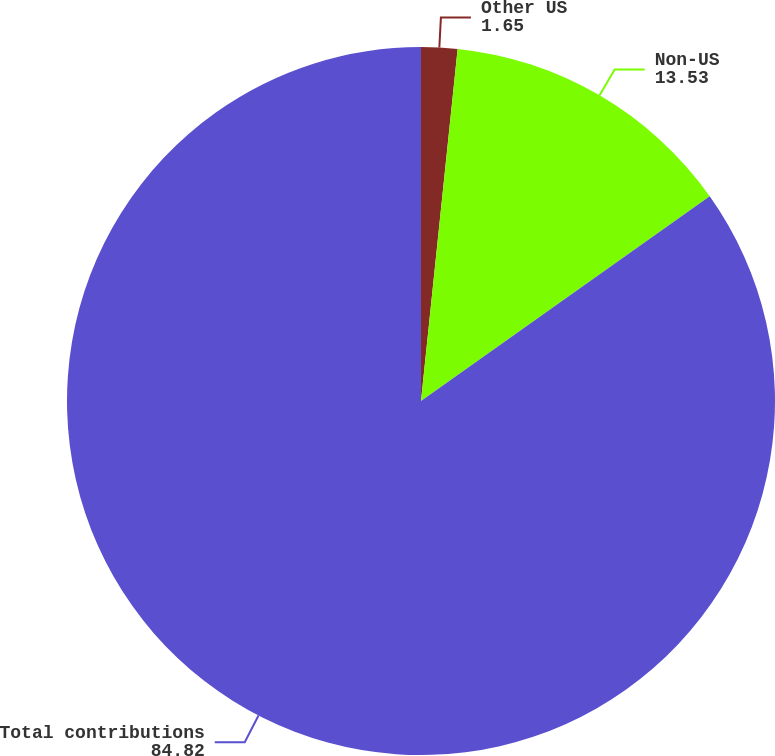Convert chart to OTSL. <chart><loc_0><loc_0><loc_500><loc_500><pie_chart><fcel>Other US<fcel>Non-US<fcel>Total contributions<nl><fcel>1.65%<fcel>13.53%<fcel>84.82%<nl></chart> 